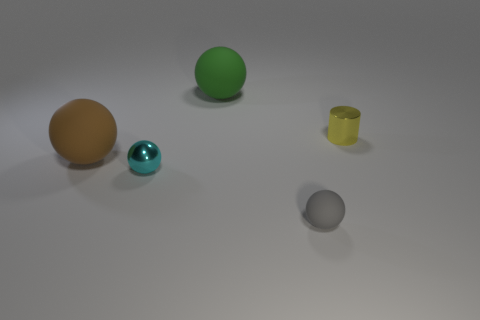Add 2 big green matte balls. How many objects exist? 7 Subtract all balls. How many objects are left? 1 Subtract 0 cyan cylinders. How many objects are left? 5 Subtract all red shiny things. Subtract all tiny gray objects. How many objects are left? 4 Add 3 small objects. How many small objects are left? 6 Add 4 cyan balls. How many cyan balls exist? 5 